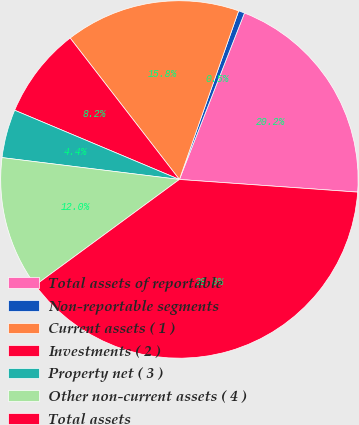<chart> <loc_0><loc_0><loc_500><loc_500><pie_chart><fcel>Total assets of reportable<fcel>Non-reportable segments<fcel>Current assets ( 1 )<fcel>Investments ( 2 )<fcel>Property net ( 3 )<fcel>Other non-current assets ( 4 )<fcel>Total assets<nl><fcel>20.2%<fcel>0.55%<fcel>15.85%<fcel>8.2%<fcel>4.38%<fcel>12.03%<fcel>38.8%<nl></chart> 